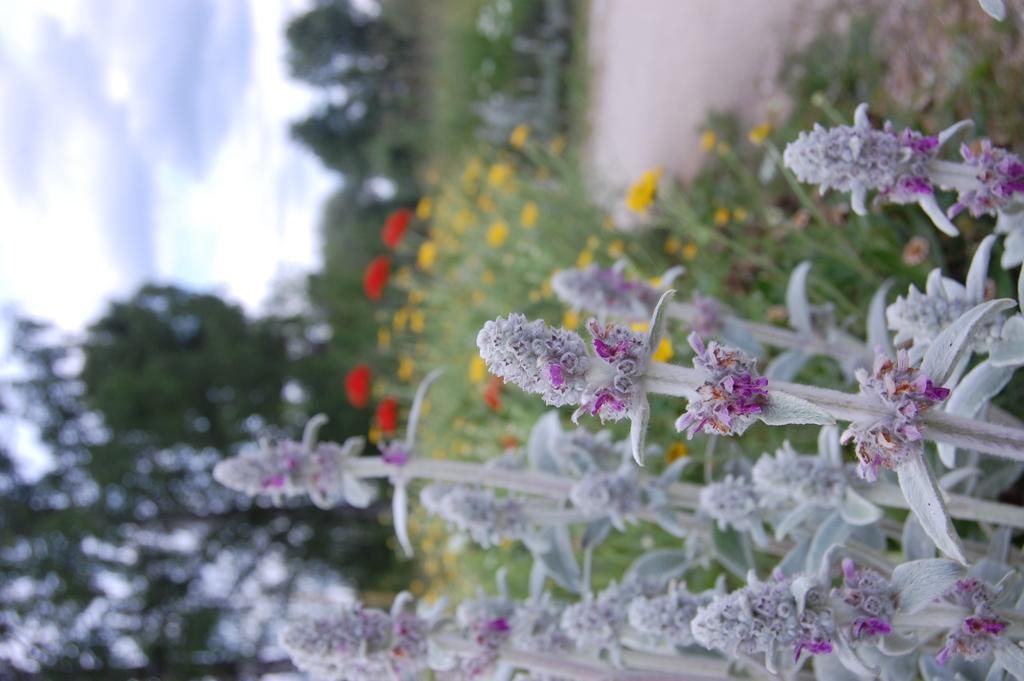What types of vegetation can be seen in the image? There are plants and flowers in the image. What can be seen in the background of the image? There are trees and the sky visible in the background of the image. What type of desk is visible in the image? There is no desk present in the image. Is there a woman interacting with the plants in the image? There is no woman present in the image. 